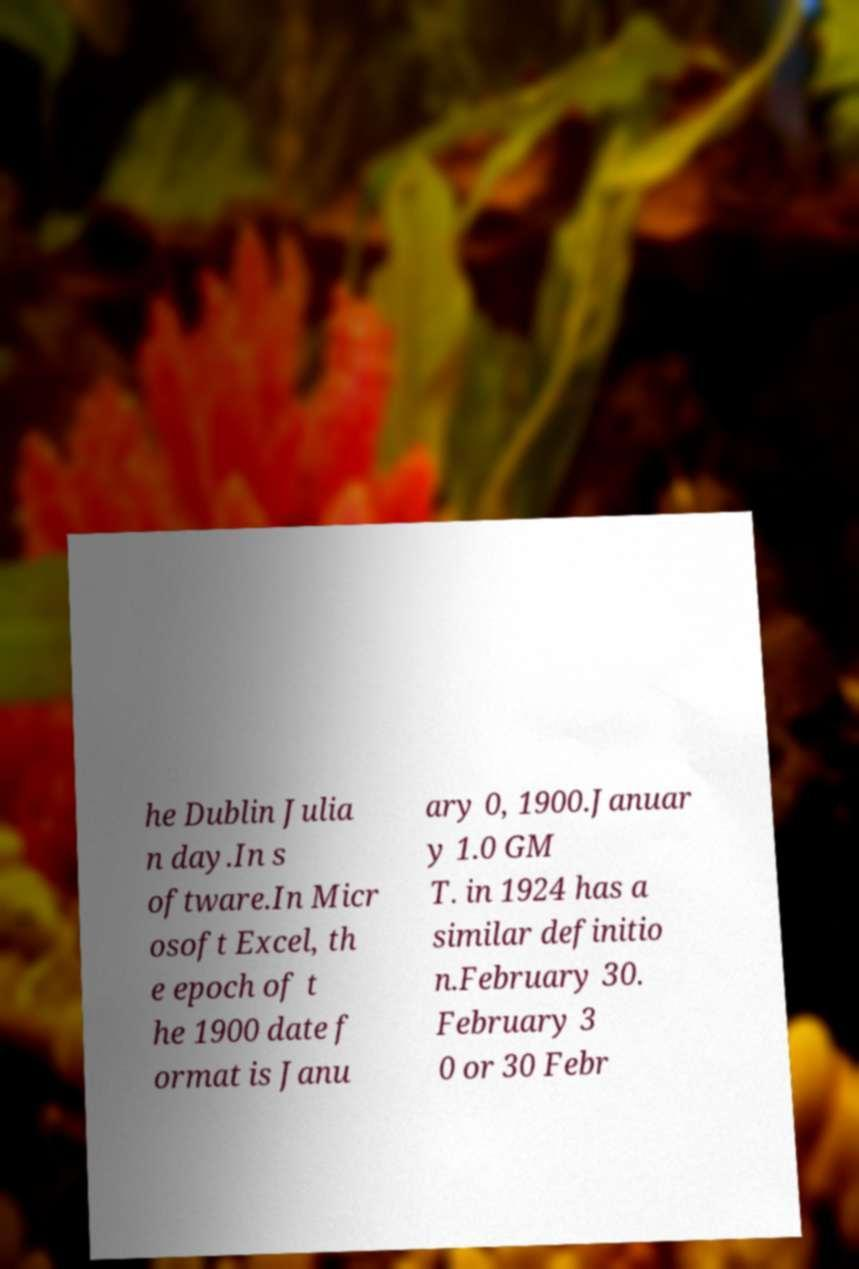Please read and relay the text visible in this image. What does it say? he Dublin Julia n day.In s oftware.In Micr osoft Excel, th e epoch of t he 1900 date f ormat is Janu ary 0, 1900.Januar y 1.0 GM T. in 1924 has a similar definitio n.February 30. February 3 0 or 30 Febr 